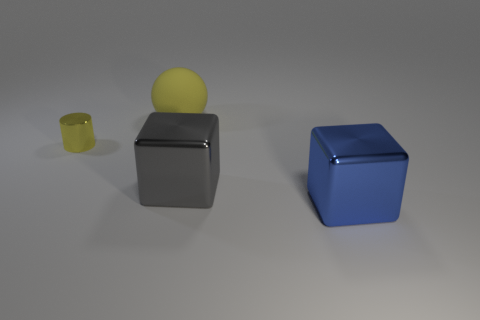Subtract all spheres. How many objects are left? 3 Add 4 cylinders. How many objects exist? 8 Subtract 0 gray spheres. How many objects are left? 4 Subtract all tiny yellow rubber cubes. Subtract all small yellow metallic cylinders. How many objects are left? 3 Add 3 matte spheres. How many matte spheres are left? 4 Add 4 red matte cylinders. How many red matte cylinders exist? 4 